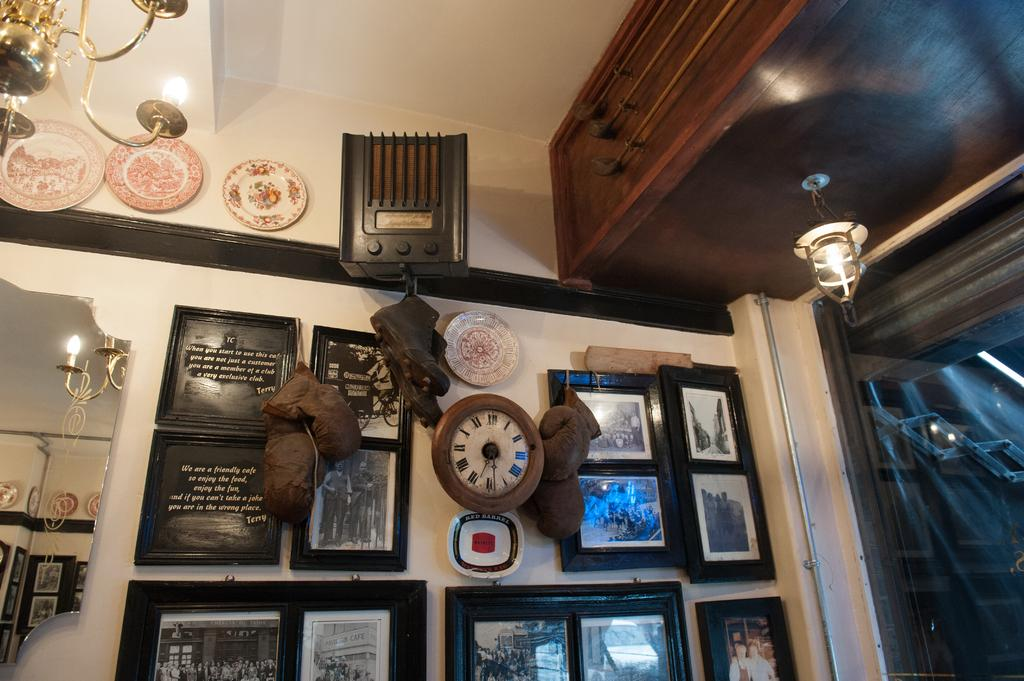What type of view does the image provide? The image shows an internal view of a room. What can be seen on the walls of the room? There are frames and a clock on the wall. What type of lighting fixture is present in the room? There is a chandelier in the room. What material is used for the wall in the room? The glass wall in the room is made of glass. What type of furniture is present in the room? There is wooden furniture in the room. Can you see any toads hopping around in the room? There are no toads present in the image; it shows an internal view of a room with various objects and features. What type of voyage is depicted in the image? The image does not depict any voyage; it shows an internal view of a room with various objects and features. 